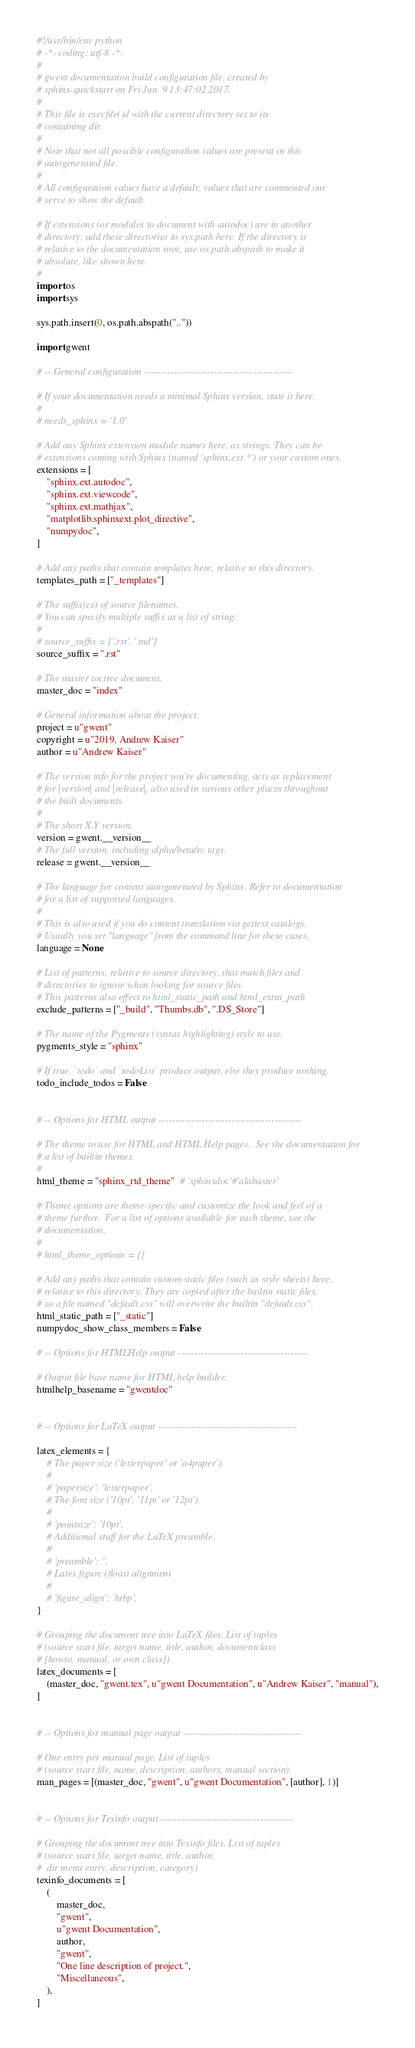Convert code to text. <code><loc_0><loc_0><loc_500><loc_500><_Python_>#!/usr/bin/env python
# -*- coding: utf-8 -*-
#
# gwent documentation build configuration file, created by
# sphinx-quickstart on Fri Jun  9 13:47:02 2017.
#
# This file is execfile()d with the current directory set to its
# containing dir.
#
# Note that not all possible configuration values are present in this
# autogenerated file.
#
# All configuration values have a default; values that are commented out
# serve to show the default.

# If extensions (or modules to document with autodoc) are in another
# directory, add these directories to sys.path here. If the directory is
# relative to the documentation root, use os.path.abspath to make it
# absolute, like shown here.
#
import os
import sys

sys.path.insert(0, os.path.abspath(".."))

import gwent

# -- General configuration ---------------------------------------------

# If your documentation needs a minimal Sphinx version, state it here.
#
# needs_sphinx = '1.0'

# Add any Sphinx extension module names here, as strings. They can be
# extensions coming with Sphinx (named 'sphinx.ext.*') or your custom ones.
extensions = [
    "sphinx.ext.autodoc",
    "sphinx.ext.viewcode",
    "sphinx.ext.mathjax",
    "matplotlib.sphinxext.plot_directive",
    "numpydoc",
]

# Add any paths that contain templates here, relative to this directory.
templates_path = ["_templates"]

# The suffix(es) of source filenames.
# You can specify multiple suffix as a list of string:
#
# source_suffix = ['.rst', '.md']
source_suffix = ".rst"

# The master toctree document.
master_doc = "index"

# General information about the project.
project = u"gwent"
copyright = u"2019, Andrew Kaiser"
author = u"Andrew Kaiser"

# The version info for the project you're documenting, acts as replacement
# for |version| and |release|, also used in various other places throughout
# the built documents.
#
# The short X.Y version.
version = gwent.__version__
# The full version, including alpha/beta/rc tags.
release = gwent.__version__

# The language for content autogenerated by Sphinx. Refer to documentation
# for a list of supported languages.
#
# This is also used if you do content translation via gettext catalogs.
# Usually you set "language" from the command line for these cases.
language = None

# List of patterns, relative to source directory, that match files and
# directories to ignore when looking for source files.
# This patterns also effect to html_static_path and html_extra_path
exclude_patterns = ["_build", "Thumbs.db", ".DS_Store"]

# The name of the Pygments (syntax highlighting) style to use.
pygments_style = "sphinx"

# If true, `todo` and `todoList` produce output, else they produce nothing.
todo_include_todos = False


# -- Options for HTML output -------------------------------------------

# The theme to use for HTML and HTML Help pages.  See the documentation for
# a list of builtin themes.
#
html_theme = "sphinx_rtd_theme"  # 'sphinxdoc'#'alabaster'

# Theme options are theme-specific and customize the look and feel of a
# theme further.  For a list of options available for each theme, see the
# documentation.
#
# html_theme_options = {}

# Add any paths that contain custom static files (such as style sheets) here,
# relative to this directory. They are copied after the builtin static files,
# so a file named "default.css" will overwrite the builtin "default.css".
html_static_path = ["_static"]
numpydoc_show_class_members = False

# -- Options for HTMLHelp output ---------------------------------------

# Output file base name for HTML help builder.
htmlhelp_basename = "gwentdoc"


# -- Options for LaTeX output ------------------------------------------

latex_elements = {
    # The paper size ('letterpaper' or 'a4paper').
    #
    # 'papersize': 'letterpaper',
    # The font size ('10pt', '11pt' or '12pt').
    #
    # 'pointsize': '10pt',
    # Additional stuff for the LaTeX preamble.
    #
    # 'preamble': '',
    # Latex figure (float) alignment
    #
    # 'figure_align': 'htbp',
}

# Grouping the document tree into LaTeX files. List of tuples
# (source start file, target name, title, author, documentclass
# [howto, manual, or own class]).
latex_documents = [
    (master_doc, "gwent.tex", u"gwent Documentation", u"Andrew Kaiser", "manual"),
]


# -- Options for manual page output ------------------------------------

# One entry per manual page. List of tuples
# (source start file, name, description, authors, manual section).
man_pages = [(master_doc, "gwent", u"gwent Documentation", [author], 1)]


# -- Options for Texinfo output ----------------------------------------

# Grouping the document tree into Texinfo files. List of tuples
# (source start file, target name, title, author,
#  dir menu entry, description, category)
texinfo_documents = [
    (
        master_doc,
        "gwent",
        u"gwent Documentation",
        author,
        "gwent",
        "One line description of project.",
        "Miscellaneous",
    ),
]
</code> 